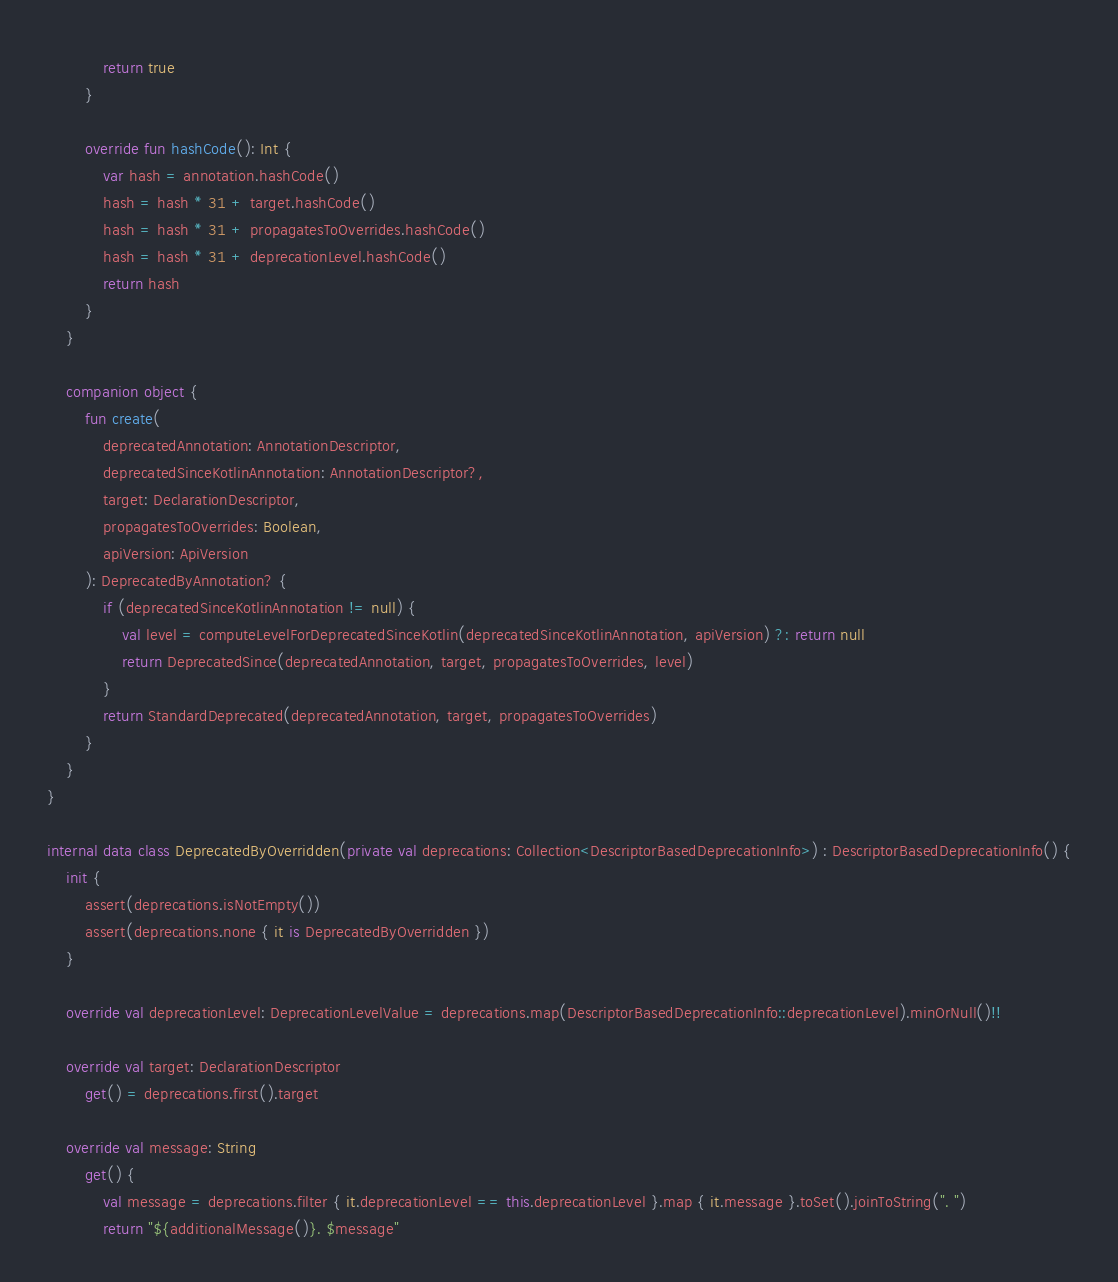Convert code to text. <code><loc_0><loc_0><loc_500><loc_500><_Kotlin_>            return true
        }

        override fun hashCode(): Int {
            var hash = annotation.hashCode()
            hash = hash * 31 + target.hashCode()
            hash = hash * 31 + propagatesToOverrides.hashCode()
            hash = hash * 31 + deprecationLevel.hashCode()
            return hash
        }
    }

    companion object {
        fun create(
            deprecatedAnnotation: AnnotationDescriptor,
            deprecatedSinceKotlinAnnotation: AnnotationDescriptor?,
            target: DeclarationDescriptor,
            propagatesToOverrides: Boolean,
            apiVersion: ApiVersion
        ): DeprecatedByAnnotation? {
            if (deprecatedSinceKotlinAnnotation != null) {
                val level = computeLevelForDeprecatedSinceKotlin(deprecatedSinceKotlinAnnotation, apiVersion) ?: return null
                return DeprecatedSince(deprecatedAnnotation, target, propagatesToOverrides, level)
            }
            return StandardDeprecated(deprecatedAnnotation, target, propagatesToOverrides)
        }
    }
}

internal data class DeprecatedByOverridden(private val deprecations: Collection<DescriptorBasedDeprecationInfo>) : DescriptorBasedDeprecationInfo() {
    init {
        assert(deprecations.isNotEmpty())
        assert(deprecations.none { it is DeprecatedByOverridden })
    }

    override val deprecationLevel: DeprecationLevelValue = deprecations.map(DescriptorBasedDeprecationInfo::deprecationLevel).minOrNull()!!

    override val target: DeclarationDescriptor
        get() = deprecations.first().target

    override val message: String
        get() {
            val message = deprecations.filter { it.deprecationLevel == this.deprecationLevel }.map { it.message }.toSet().joinToString(". ")
            return "${additionalMessage()}. $message"</code> 